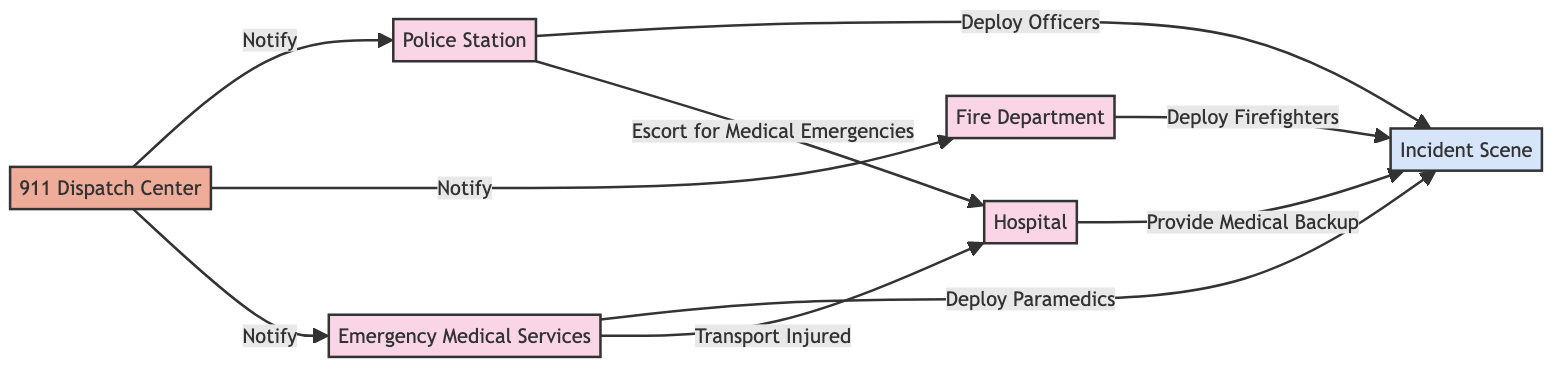What is the total number of nodes in the diagram? The diagram contains six nodes: Police Station, Fire Department, Hospital, Emergency Medical Services, 911 Dispatch Center, and Incident Scene. By counting these nodes, we establish that the total number is six.
Answer: 6 What agency is tasked with notifying all others? The 911 Dispatch Center is the only node connected to all other agencies with the "Notify" label, indicating its role in alerting them to an incident.
Answer: 911 Dispatch Center How many different actions are being deployed to the Incident Scene? There are three distinct actions being deployed to the Incident Scene from different agencies: "Deploy Officers," "Deploy Firefighters," and "Deploy Paramedics." Therefore, the number of different actions is three.
Answer: 3 Which agency transports the injured? The Emergency Medical Services node is indicated to connect to the Hospital with the edge labeled "Transport Injured," showing its responsibility for this task.
Answer: Emergency Medical Services What relationship does the Police Station have with the Hospital? The relationship between the Police Station and the Hospital is labeled "Escort for Medical Emergencies," indicating their collaboration in cases requiring transport of injured individuals.
Answer: Escort for Medical Emergencies Which location receives support from the Hospital? The Incident Scene receives support from the Hospital, as indicated by the connection with the edge labeled "Provide Medical Backup." This shows that the Hospital can assist at the location of the incident.
Answer: Incident Scene How many agencies are involved in the notification process? The 911 Dispatch Center notifies three agencies: Police Station, Fire Department, and Emergency Medical Services. Therefore, the total number of agencies involved in the notification process is three.
Answer: 3 What is the direction of the flow from the Emergency Medical Services to the Hospital? The flow from Emergency Medical Services to the Hospital is indicated by the edge labeled "Transport Injured," showing that EMS transports injured individuals to the hospital, establishing a directional relationship.
Answer: Transport Injured In total, how many edges are present in the diagram? There are eight edges depicted in the diagram, showing various interactions between the nodes, including notifications and actions being performed at the incident scene.
Answer: 8 